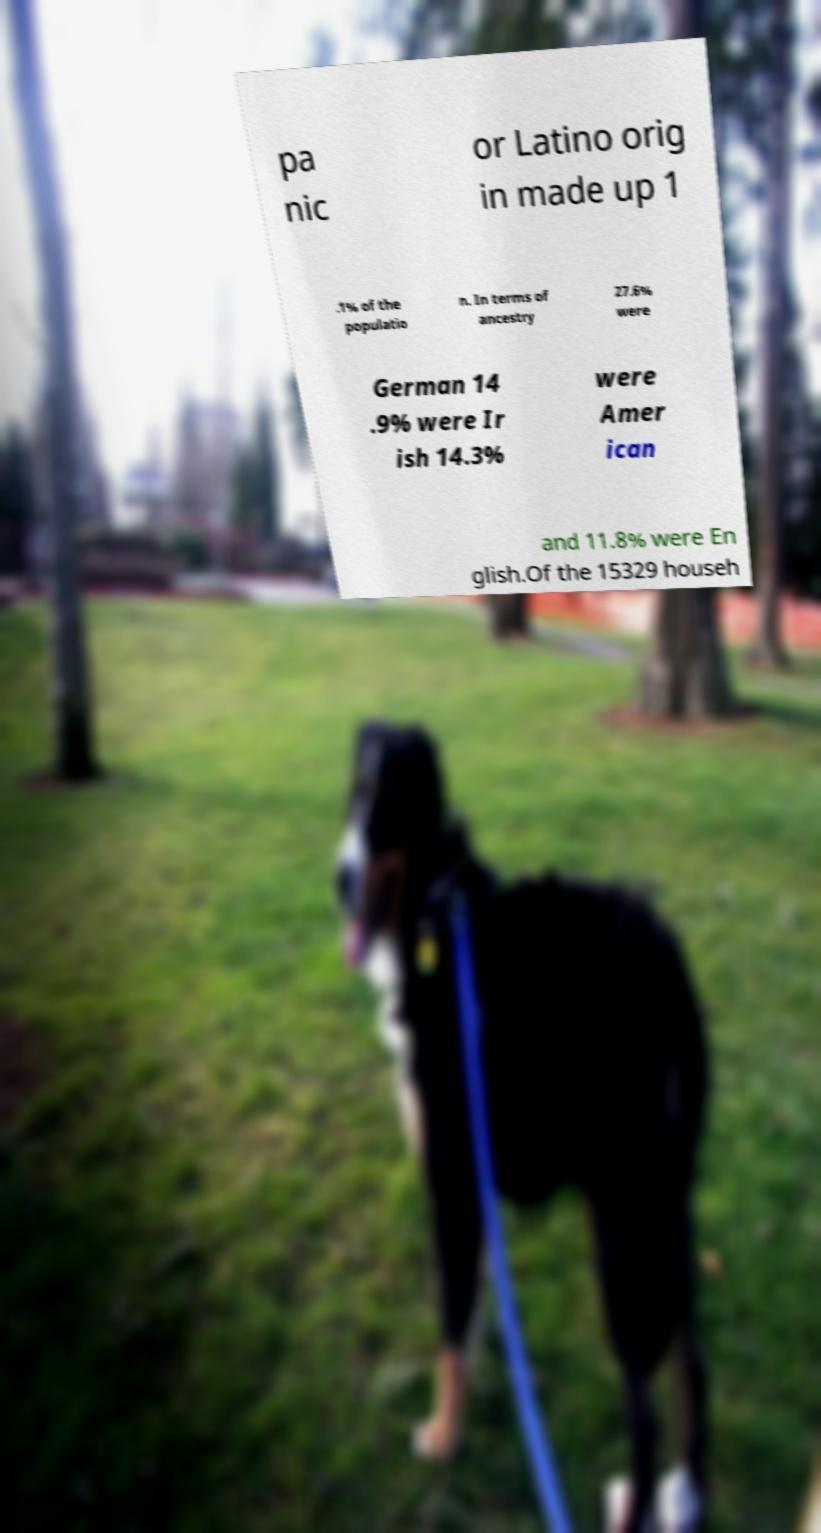Can you accurately transcribe the text from the provided image for me? pa nic or Latino orig in made up 1 .1% of the populatio n. In terms of ancestry 27.6% were German 14 .9% were Ir ish 14.3% were Amer ican and 11.8% were En glish.Of the 15329 househ 